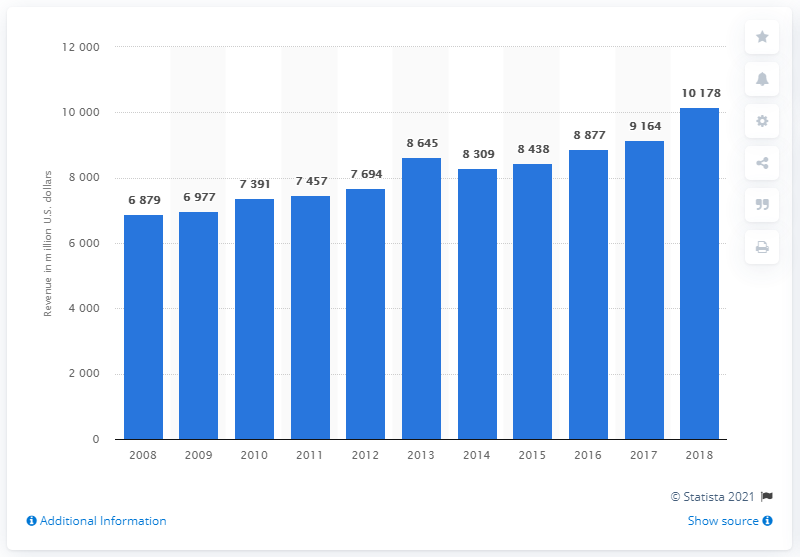Identify some key points in this picture. In 2018, the entertainment segment of CBS generated approximately $10,178 in revenue. In the previous year, CBS generated $91,640 in revenue from its entertainment segment. 